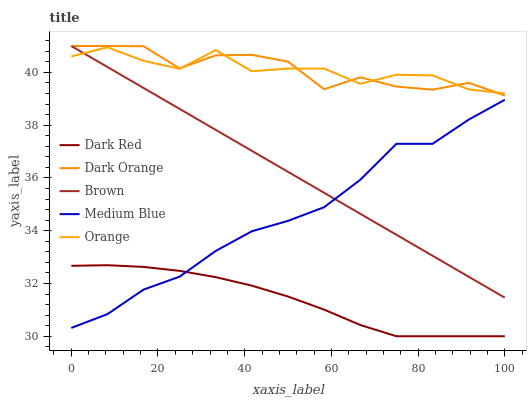Does Dark Red have the minimum area under the curve?
Answer yes or no. Yes. Does Dark Orange have the maximum area under the curve?
Answer yes or no. Yes. Does Medium Blue have the minimum area under the curve?
Answer yes or no. No. Does Medium Blue have the maximum area under the curve?
Answer yes or no. No. Is Brown the smoothest?
Answer yes or no. Yes. Is Dark Orange the roughest?
Answer yes or no. Yes. Is Dark Red the smoothest?
Answer yes or no. No. Is Dark Red the roughest?
Answer yes or no. No. Does Dark Red have the lowest value?
Answer yes or no. Yes. Does Medium Blue have the lowest value?
Answer yes or no. No. Does Dark Orange have the highest value?
Answer yes or no. Yes. Does Medium Blue have the highest value?
Answer yes or no. No. Is Dark Red less than Dark Orange?
Answer yes or no. Yes. Is Orange greater than Medium Blue?
Answer yes or no. Yes. Does Medium Blue intersect Dark Red?
Answer yes or no. Yes. Is Medium Blue less than Dark Red?
Answer yes or no. No. Is Medium Blue greater than Dark Red?
Answer yes or no. No. Does Dark Red intersect Dark Orange?
Answer yes or no. No. 